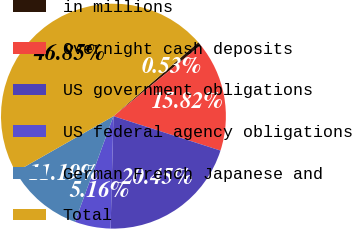Convert chart to OTSL. <chart><loc_0><loc_0><loc_500><loc_500><pie_chart><fcel>in millions<fcel>Overnight cash deposits<fcel>US government obligations<fcel>US federal agency obligations<fcel>German French Japanese and<fcel>Total<nl><fcel>0.53%<fcel>15.82%<fcel>20.45%<fcel>5.16%<fcel>11.19%<fcel>46.85%<nl></chart> 